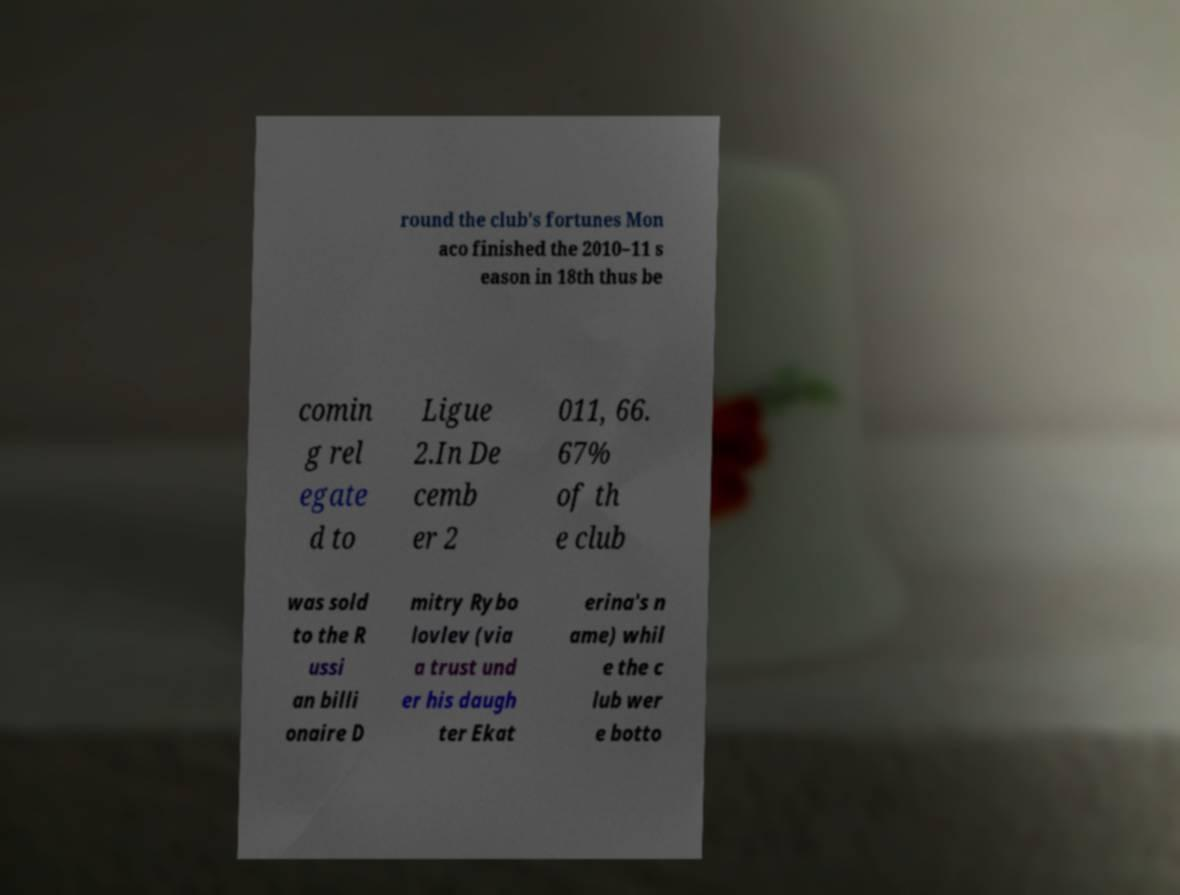Can you read and provide the text displayed in the image?This photo seems to have some interesting text. Can you extract and type it out for me? round the club's fortunes Mon aco finished the 2010–11 s eason in 18th thus be comin g rel egate d to Ligue 2.In De cemb er 2 011, 66. 67% of th e club was sold to the R ussi an billi onaire D mitry Rybo lovlev (via a trust und er his daugh ter Ekat erina's n ame) whil e the c lub wer e botto 